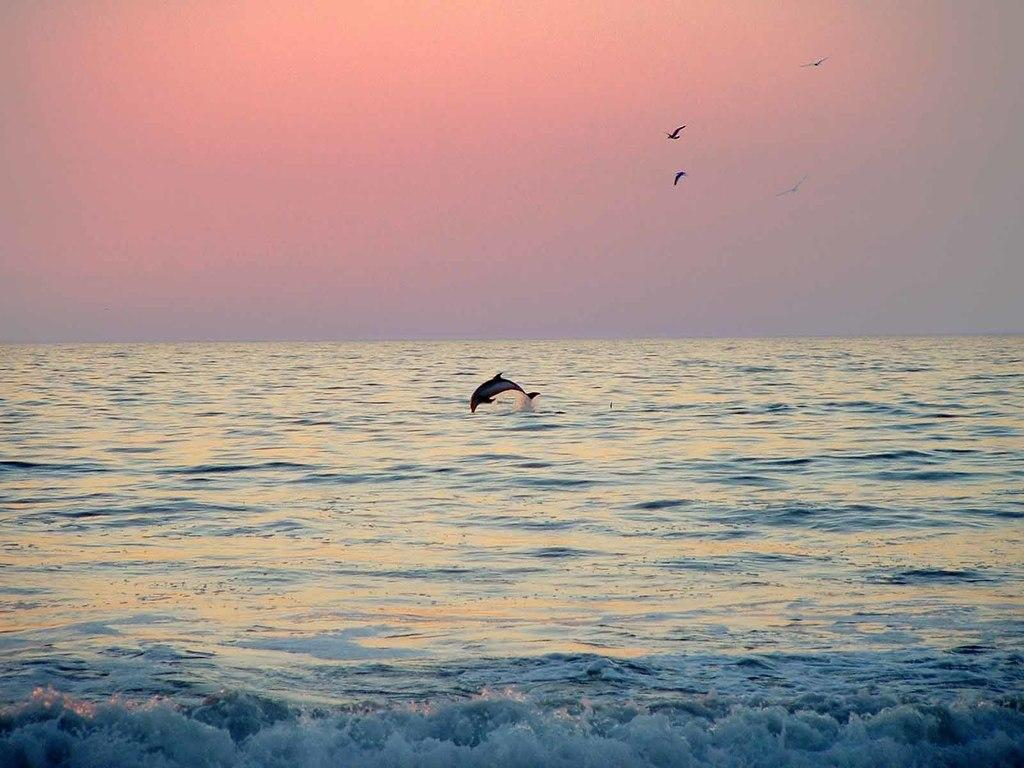Where was the picture taken? The picture was clicked outside the city. What can be seen in the foreground of the image? There is a water body in the foreground of the image. What animal is present in the water body? A dolphin is present in the water body. What is visible in the background of the image? There is a sky visible in the background of the image. What is happening in the sky? Birds are flying in the sky. What type of sponge is being used to clean the dolphin in the image? There is no sponge present in the image, and the dolphin is not being cleaned. How many beads are strung together on the sock in the image? There is no sock present in the image, and therefore no beads can be observed. 